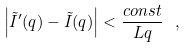<formula> <loc_0><loc_0><loc_500><loc_500>\left | \tilde { I } ^ { \prime } ( q ) - \tilde { I } ( q ) \right | < \frac { c o n s t } { L q } \ ,</formula> 